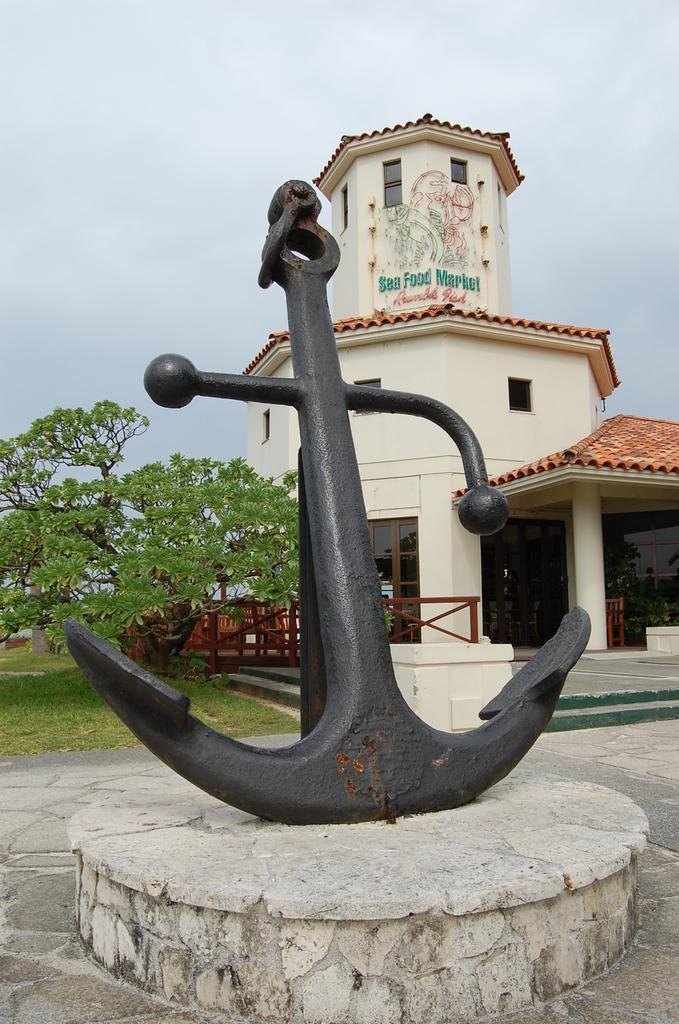What is the main object in the image? There is an anchor in the image. What color is the anchor? The anchor is black in color. What is the anchor placed on? The anchor is placed on a cement object. What can be seen in the background of the image? There is a building, a tree, and greenery on the ground in the background of the image. How would you describe the sky in the image? The sky is cloudy. Can you see any feathers floating around the anchor in the image? No, there are no feathers visible in the image. Is the anchor located near a seashore in the image? The image does not provide any information about the anchor's location in relation to a seashore. 